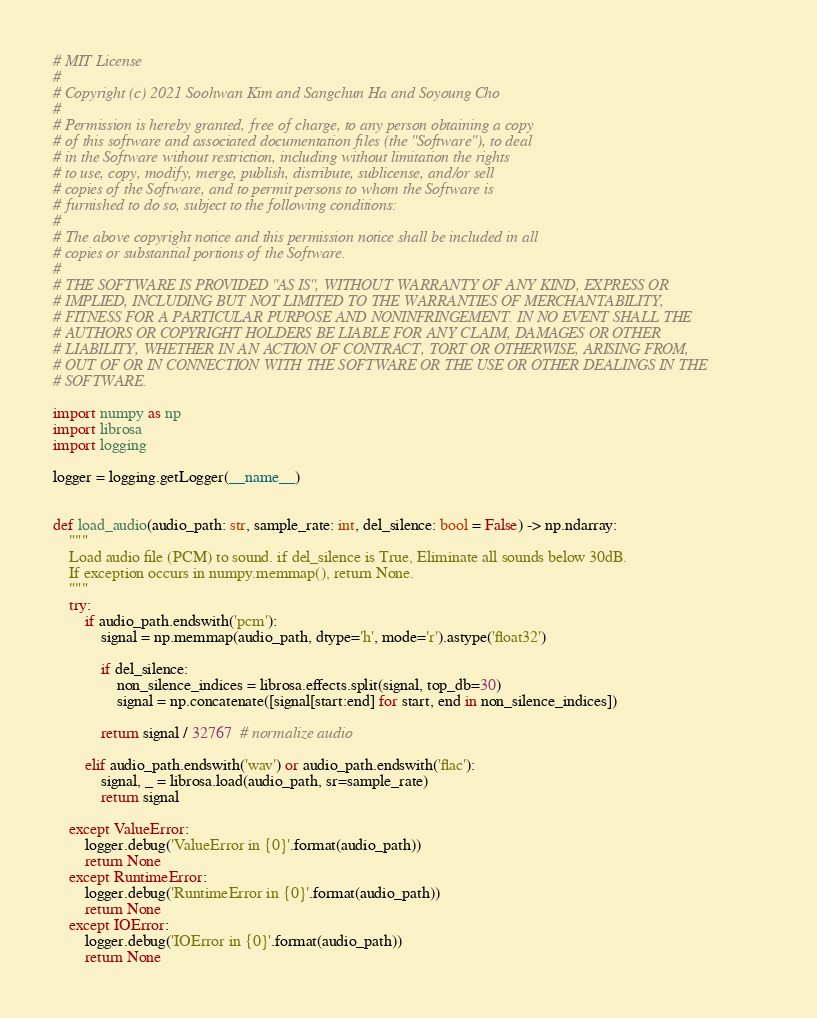<code> <loc_0><loc_0><loc_500><loc_500><_Python_># MIT License
#
# Copyright (c) 2021 Soohwan Kim and Sangchun Ha and Soyoung Cho
#
# Permission is hereby granted, free of charge, to any person obtaining a copy
# of this software and associated documentation files (the "Software"), to deal
# in the Software without restriction, including without limitation the rights
# to use, copy, modify, merge, publish, distribute, sublicense, and/or sell
# copies of the Software, and to permit persons to whom the Software is
# furnished to do so, subject to the following conditions:
#
# The above copyright notice and this permission notice shall be included in all
# copies or substantial portions of the Software.
#
# THE SOFTWARE IS PROVIDED "AS IS", WITHOUT WARRANTY OF ANY KIND, EXPRESS OR
# IMPLIED, INCLUDING BUT NOT LIMITED TO THE WARRANTIES OF MERCHANTABILITY,
# FITNESS FOR A PARTICULAR PURPOSE AND NONINFRINGEMENT. IN NO EVENT SHALL THE
# AUTHORS OR COPYRIGHT HOLDERS BE LIABLE FOR ANY CLAIM, DAMAGES OR OTHER
# LIABILITY, WHETHER IN AN ACTION OF CONTRACT, TORT OR OTHERWISE, ARISING FROM,
# OUT OF OR IN CONNECTION WITH THE SOFTWARE OR THE USE OR OTHER DEALINGS IN THE
# SOFTWARE.

import numpy as np
import librosa
import logging

logger = logging.getLogger(__name__)


def load_audio(audio_path: str, sample_rate: int, del_silence: bool = False) -> np.ndarray:
    """
    Load audio file (PCM) to sound. if del_silence is True, Eliminate all sounds below 30dB.
    If exception occurs in numpy.memmap(), return None.
    """
    try:
        if audio_path.endswith('pcm'):
            signal = np.memmap(audio_path, dtype='h', mode='r').astype('float32')

            if del_silence:
                non_silence_indices = librosa.effects.split(signal, top_db=30)
                signal = np.concatenate([signal[start:end] for start, end in non_silence_indices])

            return signal / 32767  # normalize audio

        elif audio_path.endswith('wav') or audio_path.endswith('flac'):
            signal, _ = librosa.load(audio_path, sr=sample_rate)
            return signal

    except ValueError:
        logger.debug('ValueError in {0}'.format(audio_path))
        return None
    except RuntimeError:
        logger.debug('RuntimeError in {0}'.format(audio_path))
        return None
    except IOError:
        logger.debug('IOError in {0}'.format(audio_path))
        return None
</code> 